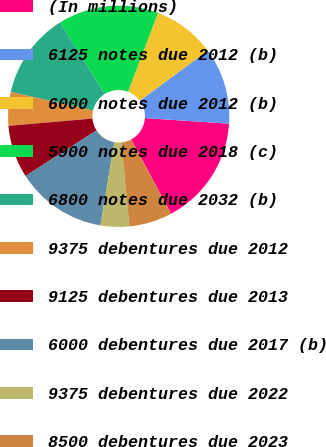Convert chart to OTSL. <chart><loc_0><loc_0><loc_500><loc_500><pie_chart><fcel>(In millions)<fcel>6125 notes due 2012 (b)<fcel>6000 notes due 2012 (b)<fcel>5900 notes due 2018 (c)<fcel>6800 notes due 2032 (b)<fcel>9375 debentures due 2012<fcel>9125 debentures due 2013<fcel>6000 debentures due 2017 (b)<fcel>9375 debentures due 2022<fcel>8500 debentures due 2023<nl><fcel>16.08%<fcel>11.19%<fcel>9.09%<fcel>14.68%<fcel>12.59%<fcel>4.9%<fcel>7.69%<fcel>13.29%<fcel>4.2%<fcel>6.29%<nl></chart> 